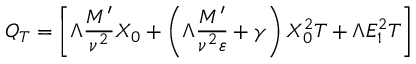Convert formula to latex. <formula><loc_0><loc_0><loc_500><loc_500>Q _ { T } = \left [ \Lambda \frac { M ^ { \prime } } { \nu ^ { 2 } } X _ { 0 } + \left ( \Lambda \frac { M ^ { \prime } } { \nu ^ { 2 } \varepsilon } + \gamma \right ) X _ { 0 } ^ { 2 } T + \Lambda E _ { 1 } ^ { 2 } T \right ]</formula> 